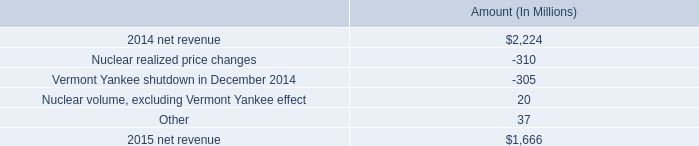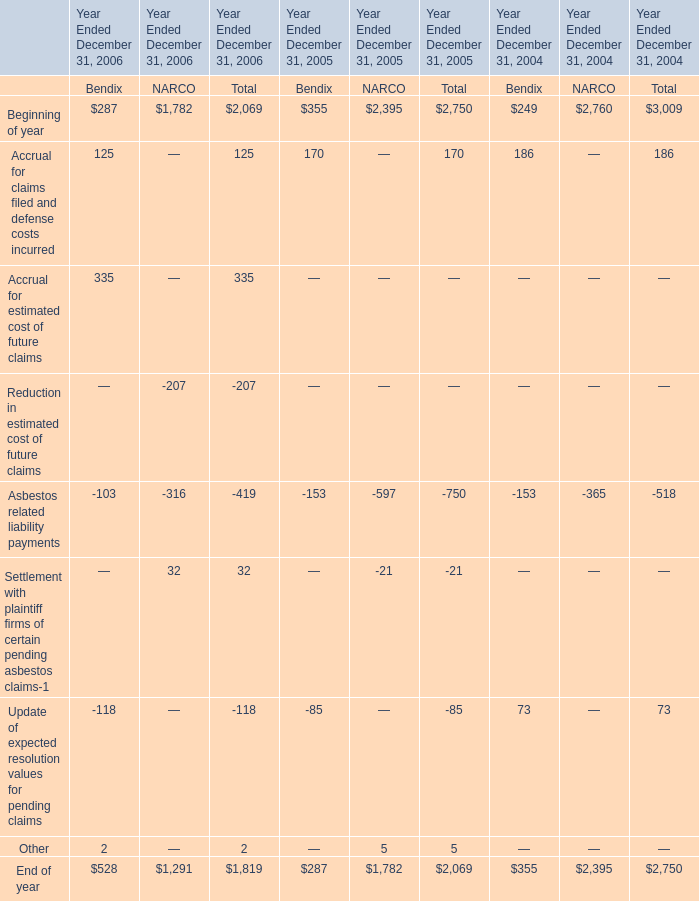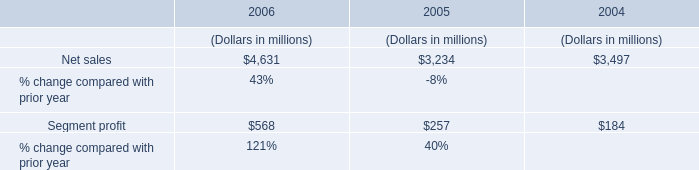What is the sum of Accrual for claims filed and defense costs incurred for Bendix in 2006 and Net sales in 2006 ? 
Computations: (125 + 4631)
Answer: 4756.0. 